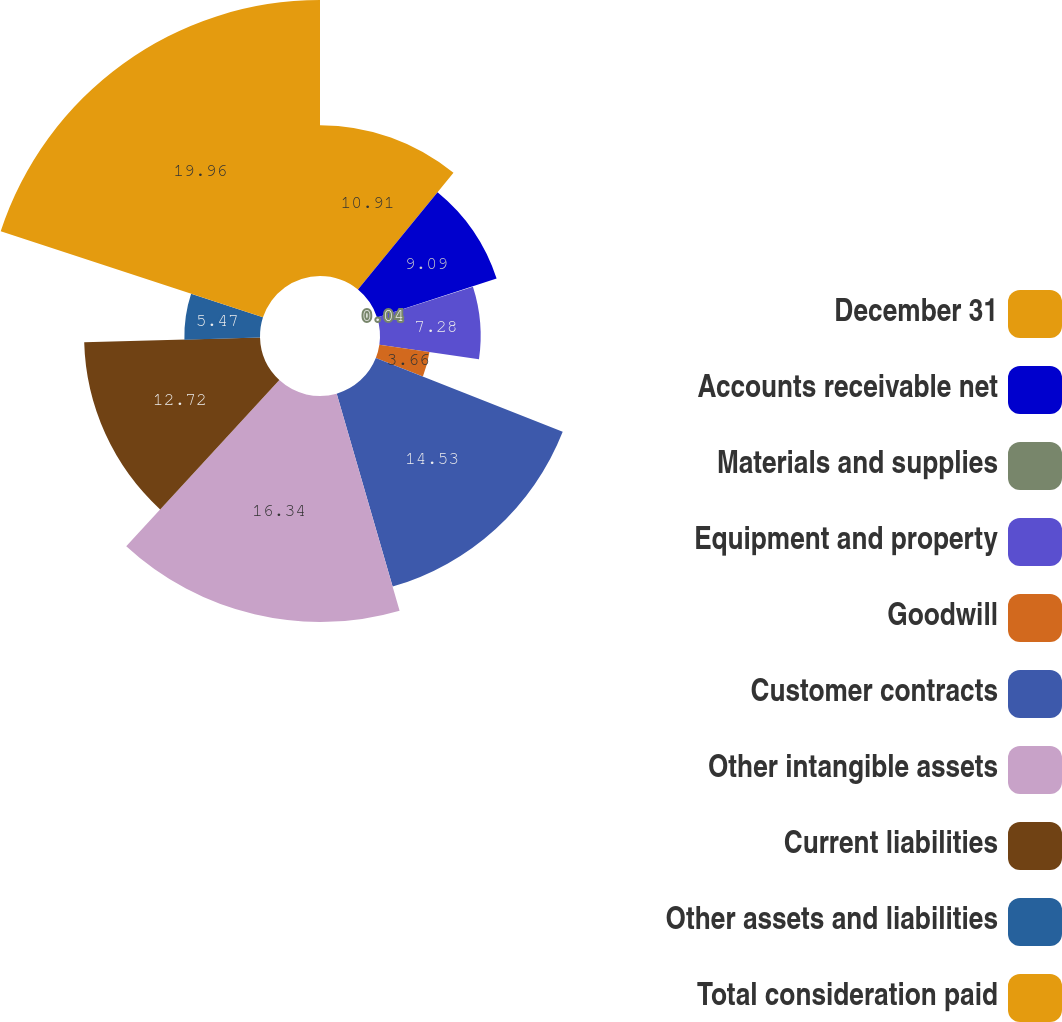<chart> <loc_0><loc_0><loc_500><loc_500><pie_chart><fcel>December 31<fcel>Accounts receivable net<fcel>Materials and supplies<fcel>Equipment and property<fcel>Goodwill<fcel>Customer contracts<fcel>Other intangible assets<fcel>Current liabilities<fcel>Other assets and liabilities<fcel>Total consideration paid<nl><fcel>10.91%<fcel>9.09%<fcel>0.04%<fcel>7.28%<fcel>3.66%<fcel>14.53%<fcel>16.34%<fcel>12.72%<fcel>5.47%<fcel>19.96%<nl></chart> 